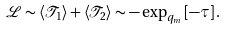<formula> <loc_0><loc_0><loc_500><loc_500>\mathcal { L } \sim \left \langle \mathcal { T } _ { 1 } \right \rangle + \left \langle \mathcal { T } _ { 2 } \right \rangle \sim - \exp _ { q _ { m } } \left [ - \tau \right ] .</formula> 